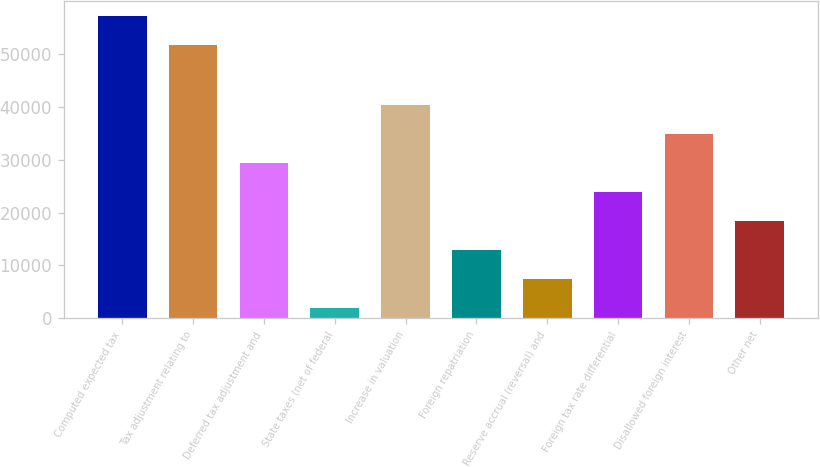<chart> <loc_0><loc_0><loc_500><loc_500><bar_chart><fcel>Computed expected tax<fcel>Tax adjustment relating to<fcel>Deferred tax adjustment and<fcel>State taxes (net of federal<fcel>Increase in valuation<fcel>Foreign repatriation<fcel>Reserve accrual (reversal) and<fcel>Foreign tax rate differential<fcel>Disallowed foreign interest<fcel>Other net<nl><fcel>57095.6<fcel>51625<fcel>29370<fcel>2017<fcel>40311.2<fcel>12958.2<fcel>7487.6<fcel>23899.4<fcel>34840.6<fcel>18428.8<nl></chart> 